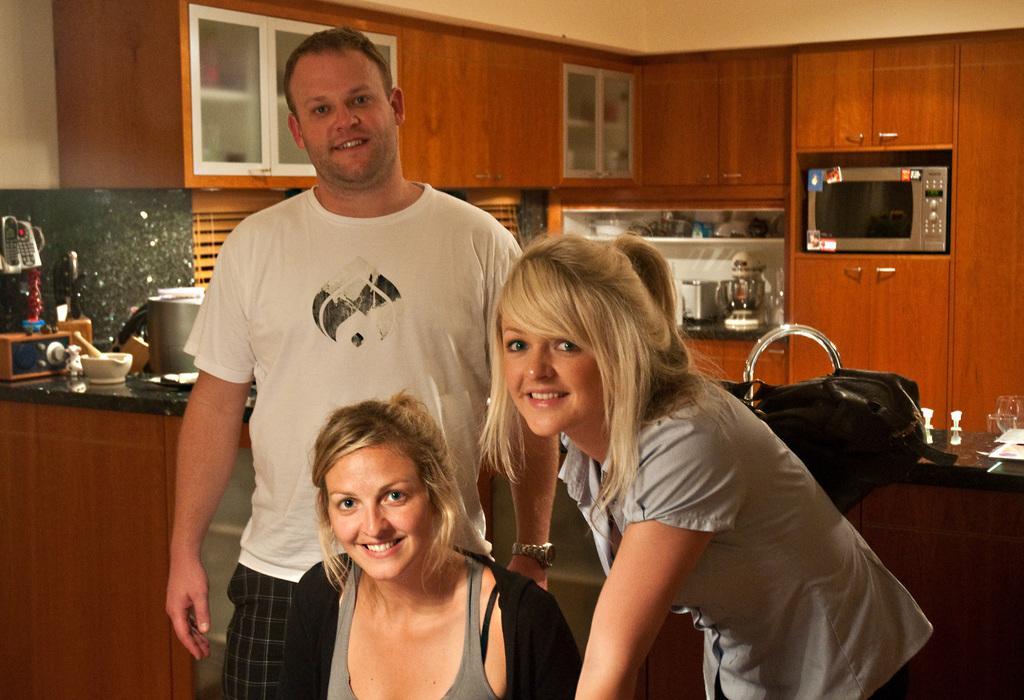In one or two sentences, can you explain what this image depicts? Here we can see three persons are posing to a camera and they are smiling. In the background we can see cupboards, oven, jar, bowls, glasses, and a bag. 